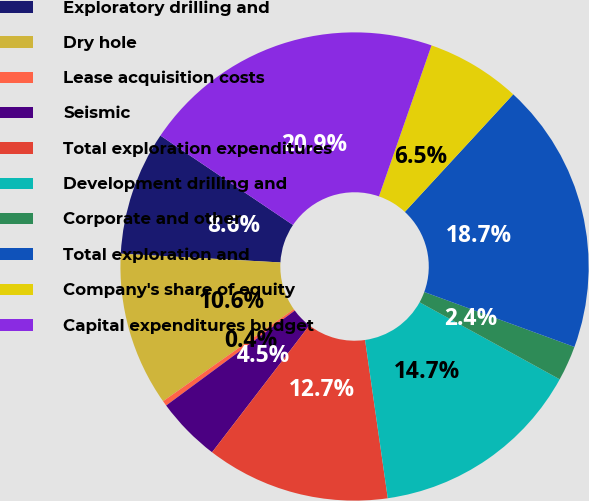<chart> <loc_0><loc_0><loc_500><loc_500><pie_chart><fcel>Exploratory drilling and<fcel>Dry hole<fcel>Lease acquisition costs<fcel>Seismic<fcel>Total exploration expenditures<fcel>Development drilling and<fcel>Corporate and other<fcel>Total exploration and<fcel>Company's share of equity<fcel>Capital expenditures budget<nl><fcel>8.57%<fcel>10.63%<fcel>0.36%<fcel>4.47%<fcel>12.68%<fcel>14.73%<fcel>2.42%<fcel>18.73%<fcel>6.52%<fcel>20.89%<nl></chart> 